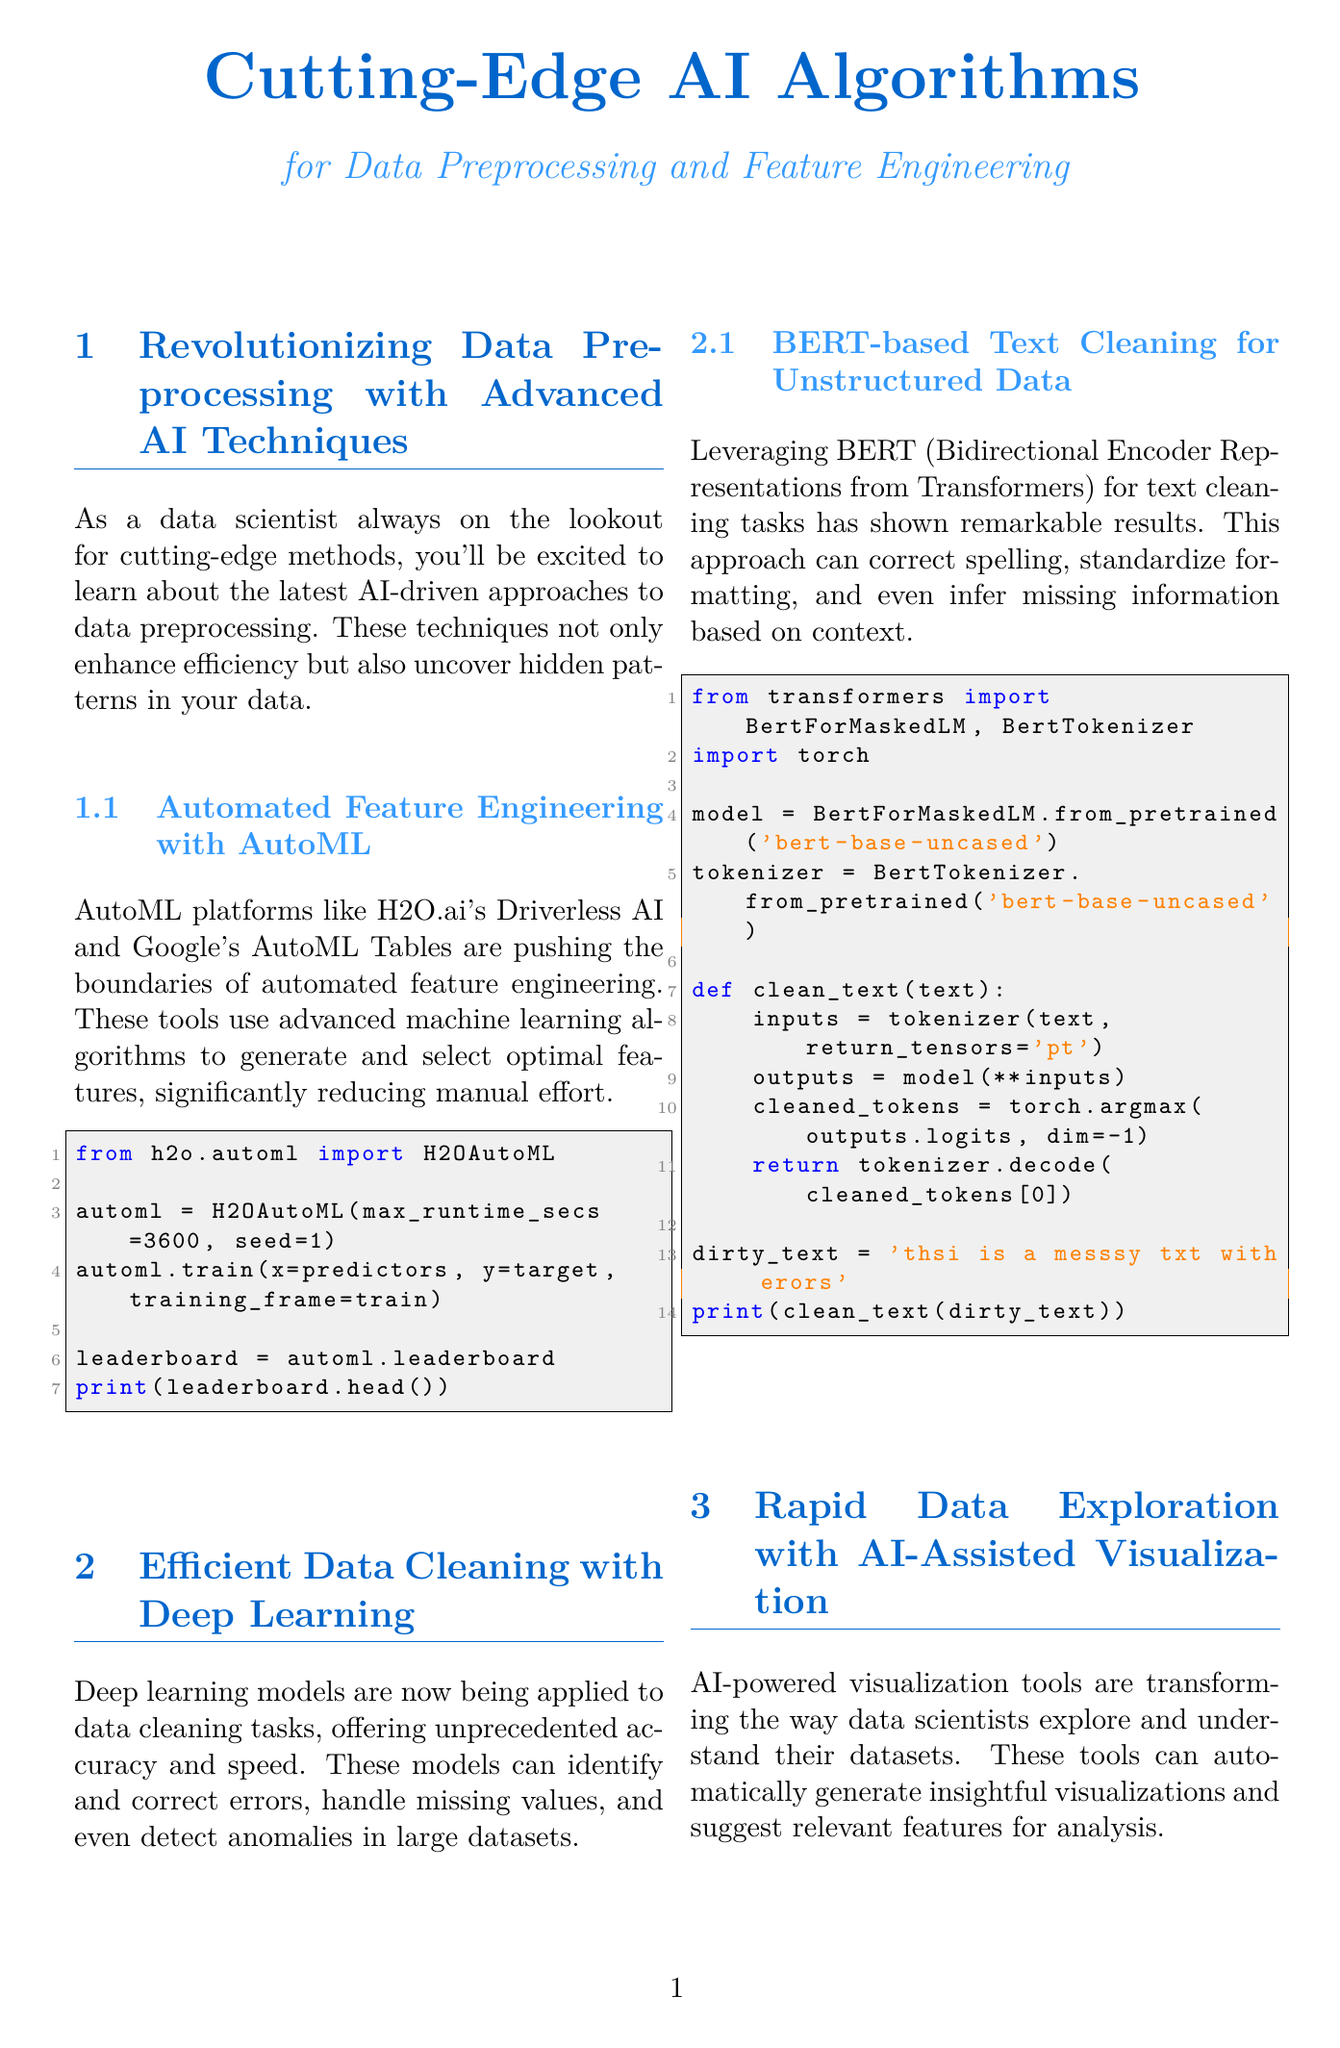What are the names of two AutoML platforms mentioned? The document highlights H2O.ai's Driverless AI and Google's AutoML Tables as leading AutoML platforms for feature engineering.
Answer: H2O.ai's Driverless AI, Google's AutoML Tables What is the time saved in feature engineering using AutoML compared to traditional methods? According to the performance comparison, the traditional approach saves 40 hours while the AutoML approach only takes 2 hours, resulting in a 95% reduction in time.
Answer: 95% reduction What accuracy percentage does BERT achieve in error correction? The document states that the BERT approach achieves an accuracy of 97% in error correction.
Answer: 97% What is the reduction in time to generate initial insights using AI-assisted visualization? Time to insights is reduced from 3 hours to 15 minutes, representing a 92% reduction in time compared to traditional methods.
Answer: 92% reduction How long does the quantum-inspired approach take to select optimal features from 1000 candidates? The performance comparison indicates that the traditional approach takes 2 hours, while the quantum-inspired approach only takes 5 minutes.
Answer: 5 minutes What improvement percentage is attributed to the BERT approach in terms of accuracy? The document specifies there is a 14% increase in accuracy when using the BERT approach.
Answer: 14% What is the method used for text cleaning as mentioned in the newsletter? The newsletter discusses using BERT (Bidirectional Encoder Representations from Transformers) for text cleaning tasks.
Answer: BERT What type of document is being referenced? The content described in the document revolves around AI algorithms for data preprocessing and feature engineering, classifying it as a newsletter.
Answer: Newsletter 